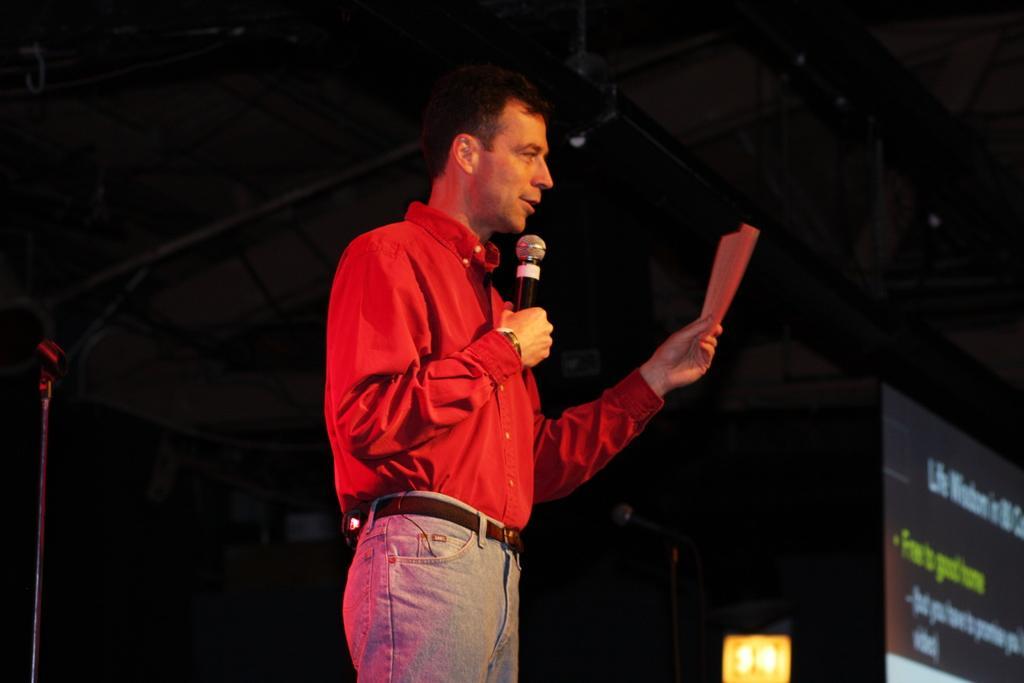Describe this image in one or two sentences. In the image there is a man in red shirt and grey jeans talking on mic holding a paper, on the right side there is a screen and the background is dark. 